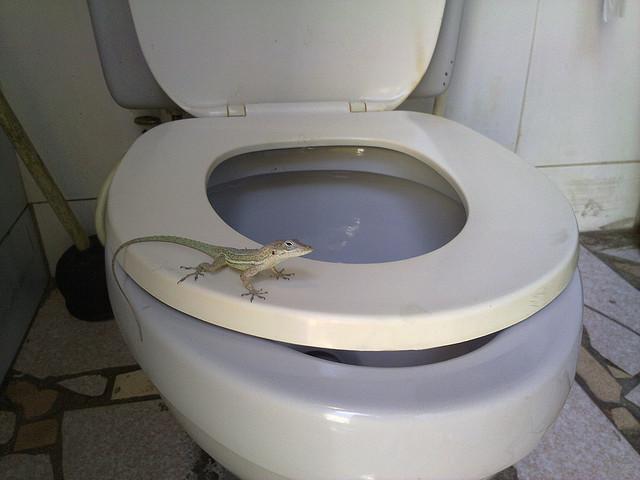What is on the toilet seat?
Keep it brief. Lizard. Does the toilet seat fit the toilet?
Keep it brief. No. In what room was the picture taken?
Short answer required. Bathroom. 